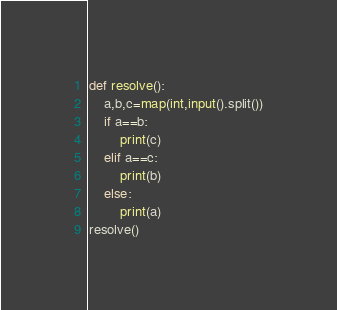<code> <loc_0><loc_0><loc_500><loc_500><_Python_>def resolve():
    a,b,c=map(int,input().split())
    if a==b:
        print(c)
    elif a==c:
        print(b)
    else:
        print(a)
resolve()</code> 